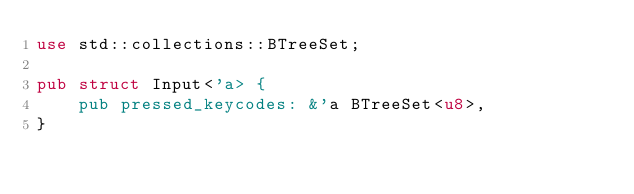Convert code to text. <code><loc_0><loc_0><loc_500><loc_500><_Rust_>use std::collections::BTreeSet;

pub struct Input<'a> {
    pub pressed_keycodes: &'a BTreeSet<u8>,
}
</code> 